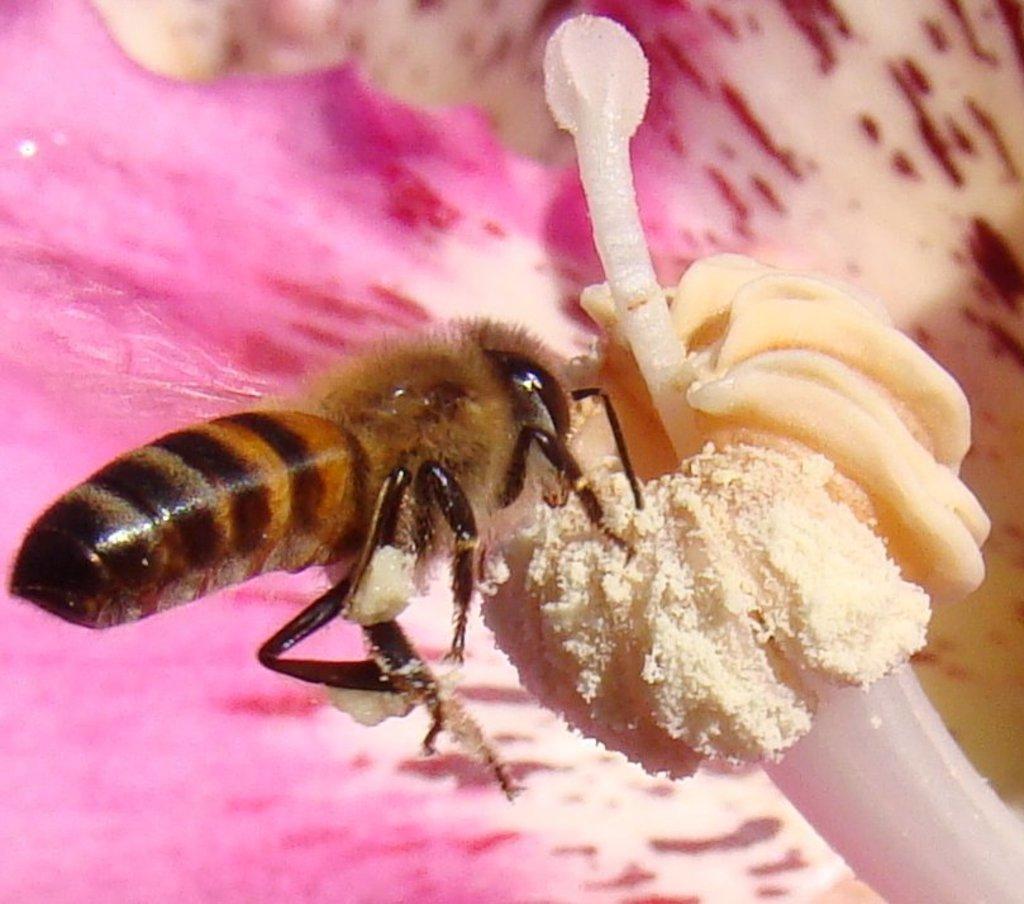Please provide a concise description of this image. In the center of the image, we can see a bee on the flower. 